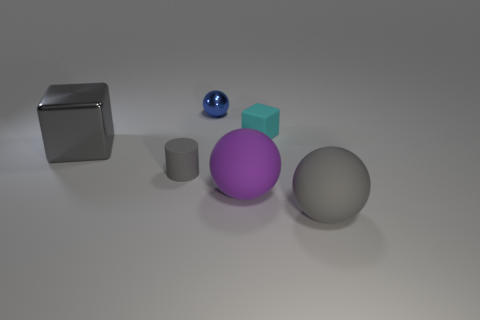Add 1 red blocks. How many objects exist? 7 Subtract all cylinders. How many objects are left? 5 Add 1 large purple spheres. How many large purple spheres are left? 2 Add 6 red cubes. How many red cubes exist? 6 Subtract 1 gray balls. How many objects are left? 5 Subtract all red spheres. Subtract all large gray objects. How many objects are left? 4 